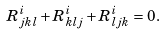<formula> <loc_0><loc_0><loc_500><loc_500>R ^ { i } _ { j k l } + R ^ { i } _ { k l j } + R ^ { i } _ { l j k } = 0 .</formula> 